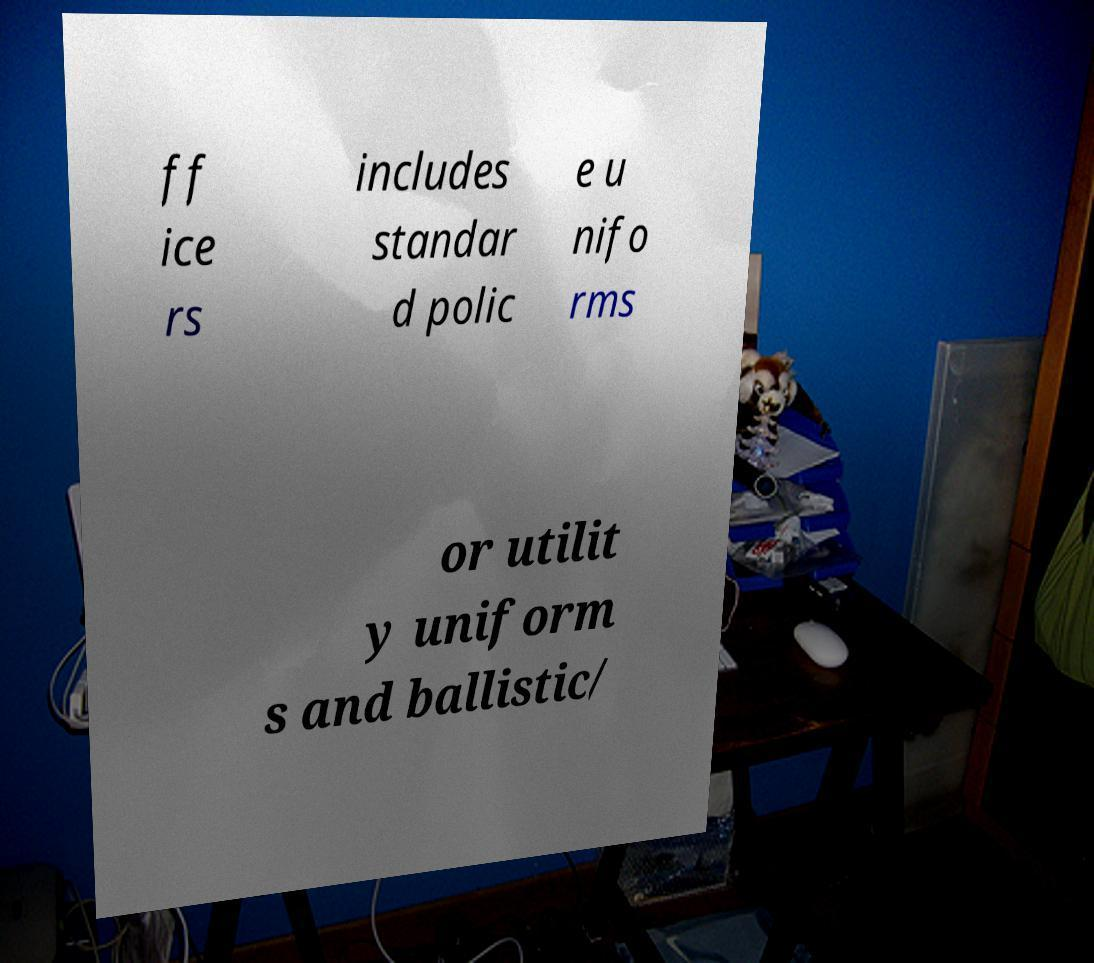Can you accurately transcribe the text from the provided image for me? ff ice rs includes standar d polic e u nifo rms or utilit y uniform s and ballistic/ 